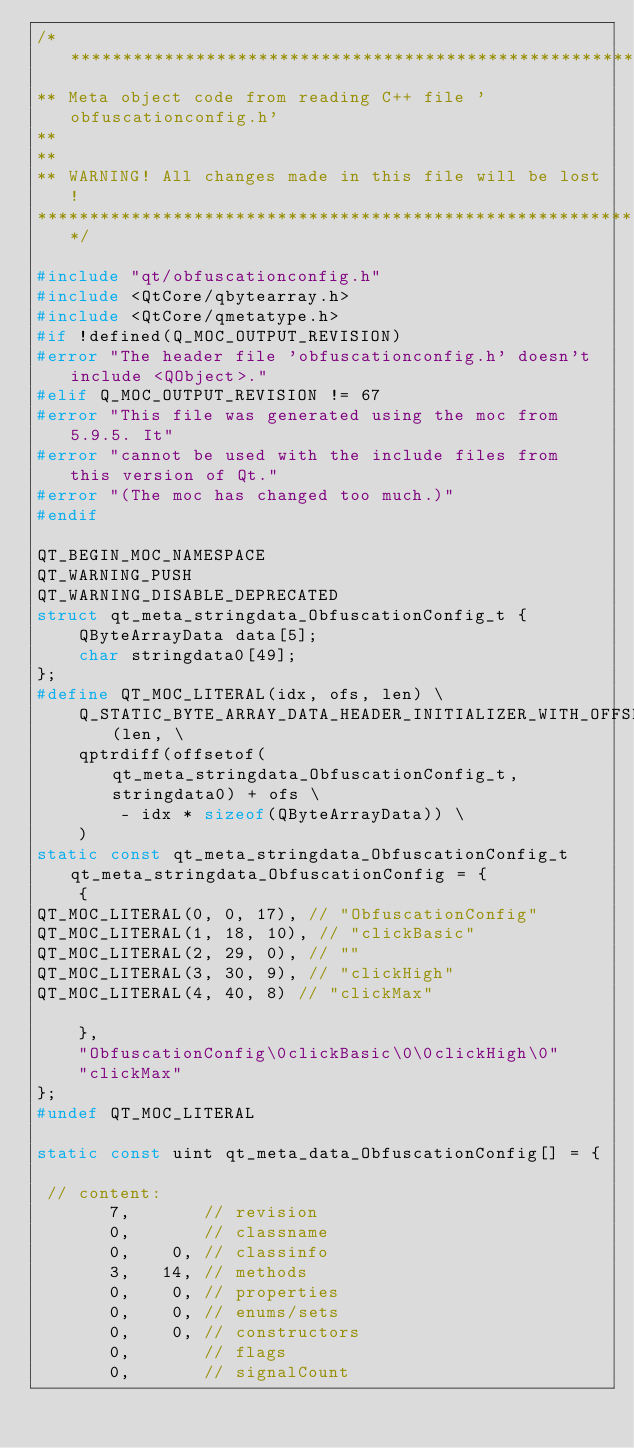<code> <loc_0><loc_0><loc_500><loc_500><_C++_>/****************************************************************************
** Meta object code from reading C++ file 'obfuscationconfig.h'
**
**
** WARNING! All changes made in this file will be lost!
*****************************************************************************/

#include "qt/obfuscationconfig.h"
#include <QtCore/qbytearray.h>
#include <QtCore/qmetatype.h>
#if !defined(Q_MOC_OUTPUT_REVISION)
#error "The header file 'obfuscationconfig.h' doesn't include <QObject>."
#elif Q_MOC_OUTPUT_REVISION != 67
#error "This file was generated using the moc from 5.9.5. It"
#error "cannot be used with the include files from this version of Qt."
#error "(The moc has changed too much.)"
#endif

QT_BEGIN_MOC_NAMESPACE
QT_WARNING_PUSH
QT_WARNING_DISABLE_DEPRECATED
struct qt_meta_stringdata_ObfuscationConfig_t {
    QByteArrayData data[5];
    char stringdata0[49];
};
#define QT_MOC_LITERAL(idx, ofs, len) \
    Q_STATIC_BYTE_ARRAY_DATA_HEADER_INITIALIZER_WITH_OFFSET(len, \
    qptrdiff(offsetof(qt_meta_stringdata_ObfuscationConfig_t, stringdata0) + ofs \
        - idx * sizeof(QByteArrayData)) \
    )
static const qt_meta_stringdata_ObfuscationConfig_t qt_meta_stringdata_ObfuscationConfig = {
    {
QT_MOC_LITERAL(0, 0, 17), // "ObfuscationConfig"
QT_MOC_LITERAL(1, 18, 10), // "clickBasic"
QT_MOC_LITERAL(2, 29, 0), // ""
QT_MOC_LITERAL(3, 30, 9), // "clickHigh"
QT_MOC_LITERAL(4, 40, 8) // "clickMax"

    },
    "ObfuscationConfig\0clickBasic\0\0clickHigh\0"
    "clickMax"
};
#undef QT_MOC_LITERAL

static const uint qt_meta_data_ObfuscationConfig[] = {

 // content:
       7,       // revision
       0,       // classname
       0,    0, // classinfo
       3,   14, // methods
       0,    0, // properties
       0,    0, // enums/sets
       0,    0, // constructors
       0,       // flags
       0,       // signalCount
</code> 